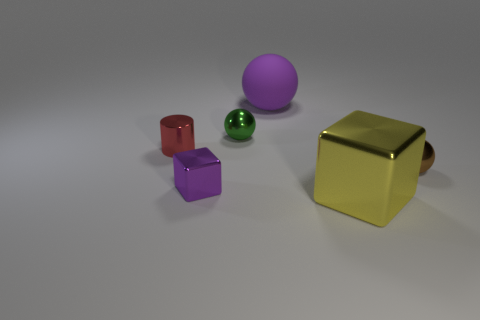Subtract all shiny spheres. How many spheres are left? 1 Subtract all yellow cubes. How many cubes are left? 1 Subtract 2 blocks. How many blocks are left? 0 Subtract all green rubber objects. Subtract all big purple matte balls. How many objects are left? 5 Add 1 large purple matte objects. How many large purple matte objects are left? 2 Add 2 green metallic spheres. How many green metallic spheres exist? 3 Add 2 big purple spheres. How many objects exist? 8 Subtract 0 cyan cylinders. How many objects are left? 6 Subtract all cylinders. How many objects are left? 5 Subtract all gray balls. Subtract all purple blocks. How many balls are left? 3 